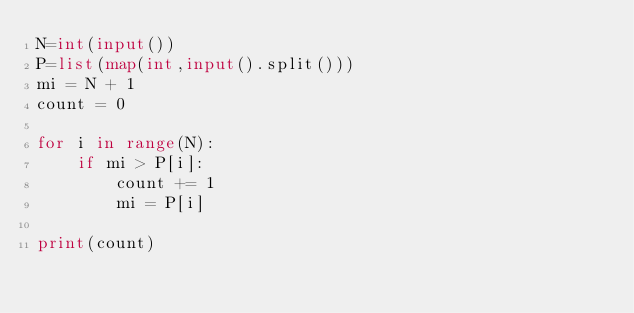Convert code to text. <code><loc_0><loc_0><loc_500><loc_500><_Python_>N=int(input())
P=list(map(int,input().split()))
mi = N + 1
count = 0

for i in range(N):
	if mi > P[i]:
		count += 1
		mi = P[i]

print(count)</code> 